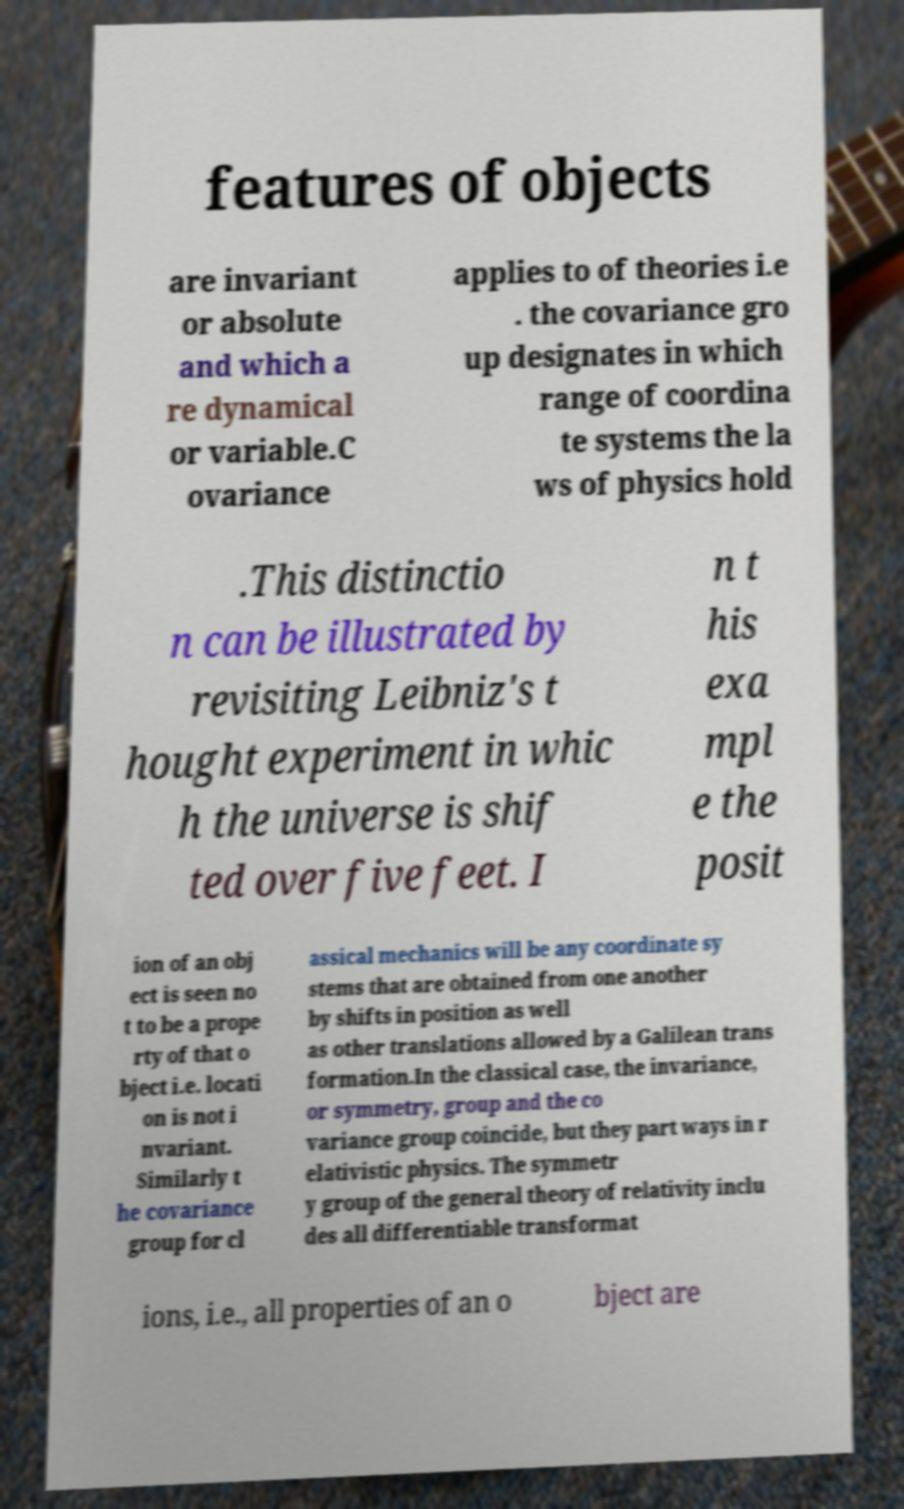Please read and relay the text visible in this image. What does it say? features of objects are invariant or absolute and which a re dynamical or variable.C ovariance applies to of theories i.e . the covariance gro up designates in which range of coordina te systems the la ws of physics hold .This distinctio n can be illustrated by revisiting Leibniz's t hought experiment in whic h the universe is shif ted over five feet. I n t his exa mpl e the posit ion of an obj ect is seen no t to be a prope rty of that o bject i.e. locati on is not i nvariant. Similarly t he covariance group for cl assical mechanics will be any coordinate sy stems that are obtained from one another by shifts in position as well as other translations allowed by a Galilean trans formation.In the classical case, the invariance, or symmetry, group and the co variance group coincide, but they part ways in r elativistic physics. The symmetr y group of the general theory of relativity inclu des all differentiable transformat ions, i.e., all properties of an o bject are 